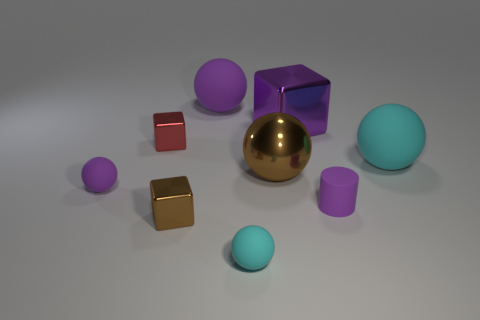Subtract all tiny purple matte spheres. How many spheres are left? 4 Subtract 4 balls. How many balls are left? 1 Subtract all tiny brown metal balls. Subtract all rubber spheres. How many objects are left? 5 Add 6 shiny things. How many shiny things are left? 10 Add 1 metallic blocks. How many metallic blocks exist? 4 Subtract all brown balls. How many balls are left? 4 Subtract 0 red balls. How many objects are left? 9 Subtract all balls. How many objects are left? 4 Subtract all gray cylinders. Subtract all brown blocks. How many cylinders are left? 1 Subtract all brown spheres. How many yellow cubes are left? 0 